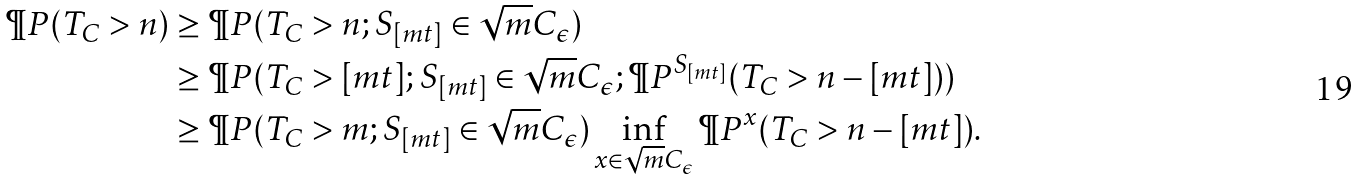<formula> <loc_0><loc_0><loc_500><loc_500>\P P ( T _ { C } > n ) & \geq \P P ( T _ { C } > n ; S _ { [ m t ] } \in \sqrt { m } C _ { \epsilon } ) \\ & \geq \P P ( T _ { C } > [ m t ] ; S _ { [ m t ] } \in \sqrt { m } C _ { \epsilon } ; \P P ^ { S _ { [ m t ] } } ( T _ { C } > n - [ m t ] ) ) \\ & \geq \P P ( T _ { C } > m ; S _ { [ m t ] } \in \sqrt { m } C _ { \epsilon } ) \inf _ { x \in \sqrt { m } C _ { \epsilon } } \P P ^ { x } ( T _ { C } > n - [ m t ] ) .</formula> 